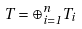Convert formula to latex. <formula><loc_0><loc_0><loc_500><loc_500>T = \oplus _ { i = 1 } ^ { n } T _ { i }</formula> 